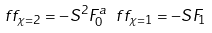Convert formula to latex. <formula><loc_0><loc_0><loc_500><loc_500>\ f f _ { \chi = 2 } = - S ^ { 2 } F _ { 0 } ^ { a } \ f f _ { \chi = 1 } = - S F _ { 1 }</formula> 